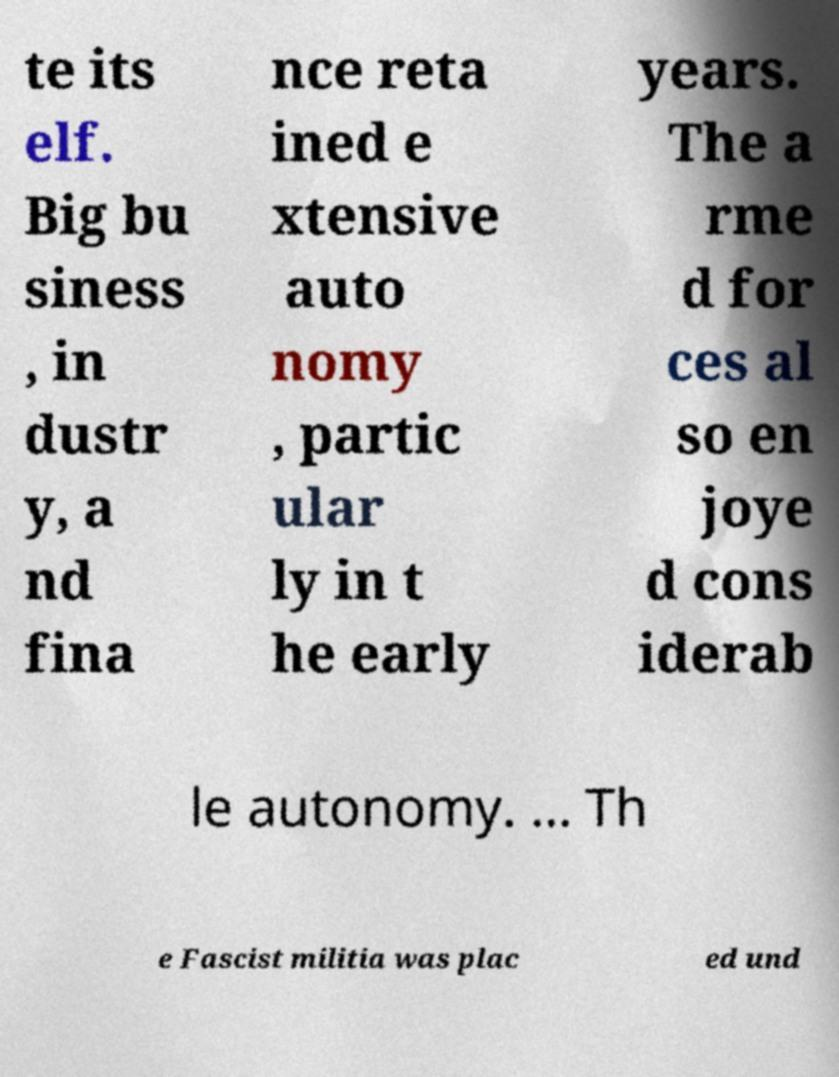Can you read and provide the text displayed in the image?This photo seems to have some interesting text. Can you extract and type it out for me? te its elf. Big bu siness , in dustr y, a nd fina nce reta ined e xtensive auto nomy , partic ular ly in t he early years. The a rme d for ces al so en joye d cons iderab le autonomy. ... Th e Fascist militia was plac ed und 